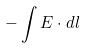Convert formula to latex. <formula><loc_0><loc_0><loc_500><loc_500>- \int E \cdot d l</formula> 